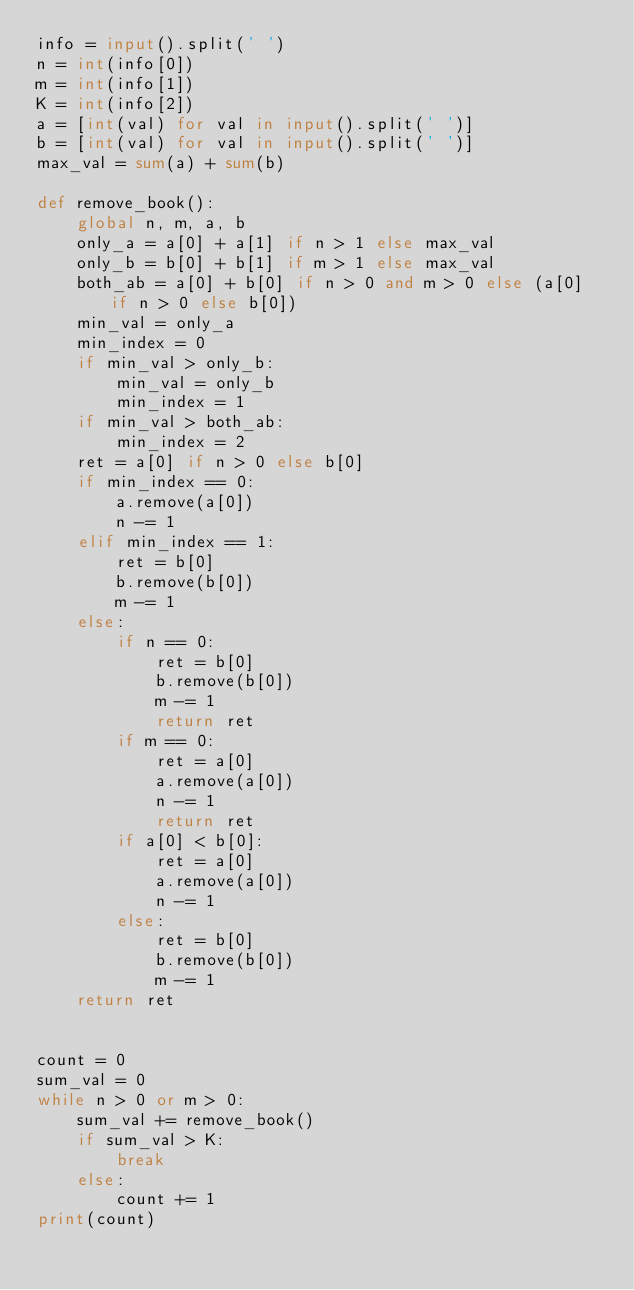<code> <loc_0><loc_0><loc_500><loc_500><_Python_>info = input().split(' ')
n = int(info[0])
m = int(info[1])
K = int(info[2])
a = [int(val) for val in input().split(' ')]
b = [int(val) for val in input().split(' ')]
max_val = sum(a) + sum(b)

def remove_book():
    global n, m, a, b
    only_a = a[0] + a[1] if n > 1 else max_val
    only_b = b[0] + b[1] if m > 1 else max_val
    both_ab = a[0] + b[0] if n > 0 and m > 0 else (a[0] if n > 0 else b[0])
    min_val = only_a
    min_index = 0
    if min_val > only_b:
        min_val = only_b
        min_index = 1
    if min_val > both_ab:
        min_index = 2
    ret = a[0] if n > 0 else b[0]
    if min_index == 0:
        a.remove(a[0])
        n -= 1
    elif min_index == 1:
        ret = b[0]
        b.remove(b[0])
        m -= 1
    else:
        if n == 0:
            ret = b[0]
            b.remove(b[0])
            m -= 1
            return ret
        if m == 0:
            ret = a[0]
            a.remove(a[0])
            n -= 1
            return ret
        if a[0] < b[0]:
            ret = a[0]
            a.remove(a[0])
            n -= 1
        else:
            ret = b[0]
            b.remove(b[0])
            m -= 1
    return ret


count = 0
sum_val = 0
while n > 0 or m > 0:
    sum_val += remove_book()
    if sum_val > K:
        break
    else:
        count += 1
print(count)
</code> 